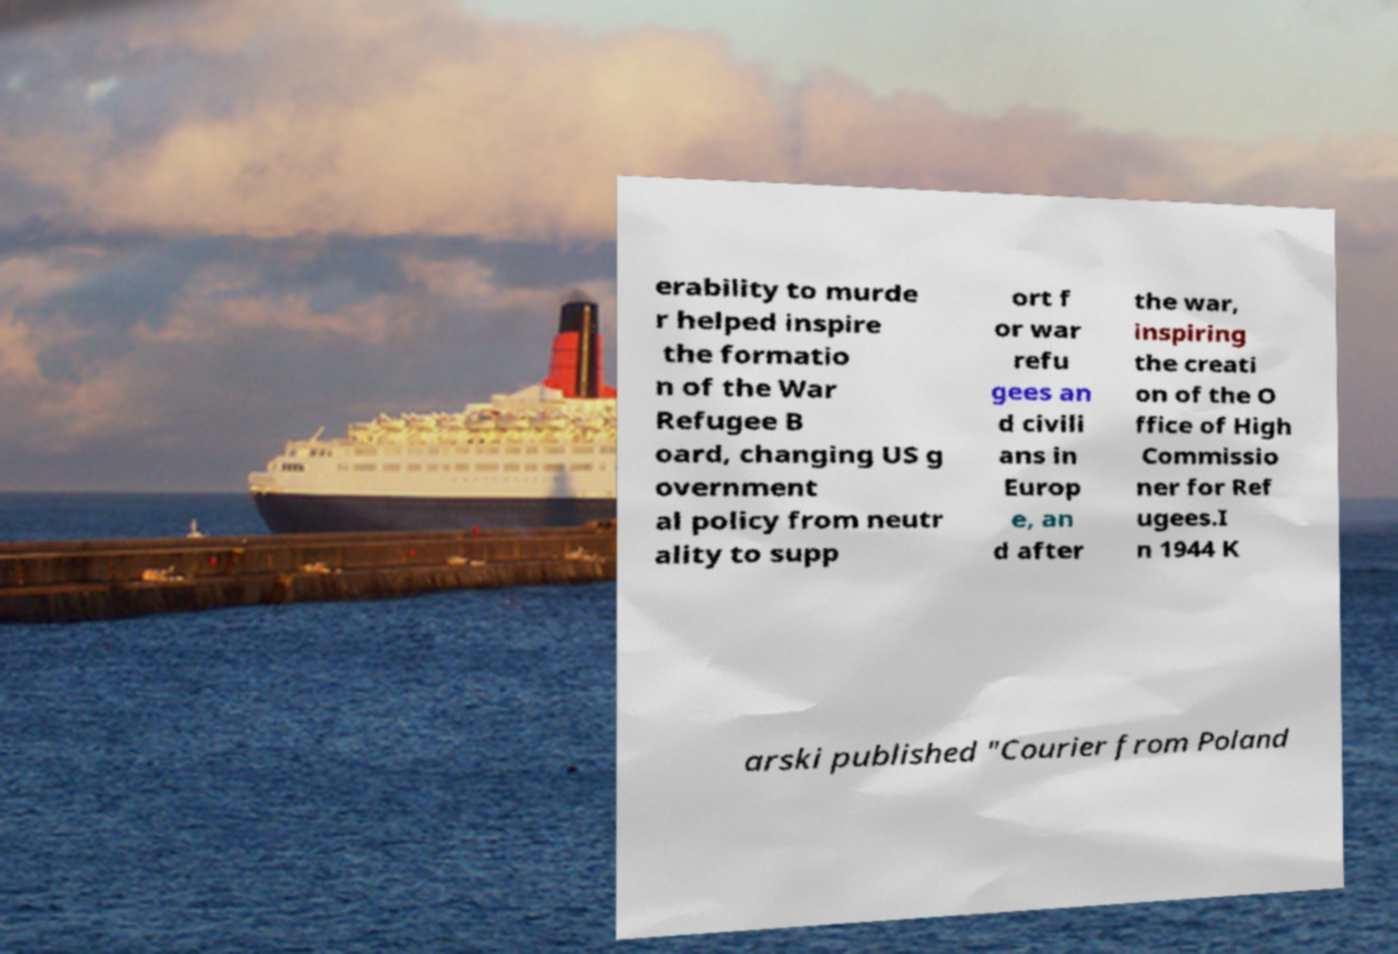Can you read and provide the text displayed in the image?This photo seems to have some interesting text. Can you extract and type it out for me? erability to murde r helped inspire the formatio n of the War Refugee B oard, changing US g overnment al policy from neutr ality to supp ort f or war refu gees an d civili ans in Europ e, an d after the war, inspiring the creati on of the O ffice of High Commissio ner for Ref ugees.I n 1944 K arski published "Courier from Poland 